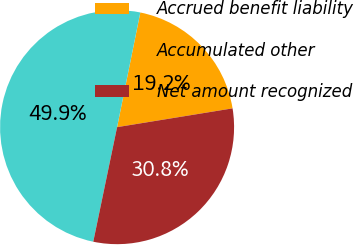Convert chart to OTSL. <chart><loc_0><loc_0><loc_500><loc_500><pie_chart><fcel>Accrued benefit liability<fcel>Accumulated other<fcel>Net amount recognized<nl><fcel>19.25%<fcel>49.92%<fcel>30.83%<nl></chart> 